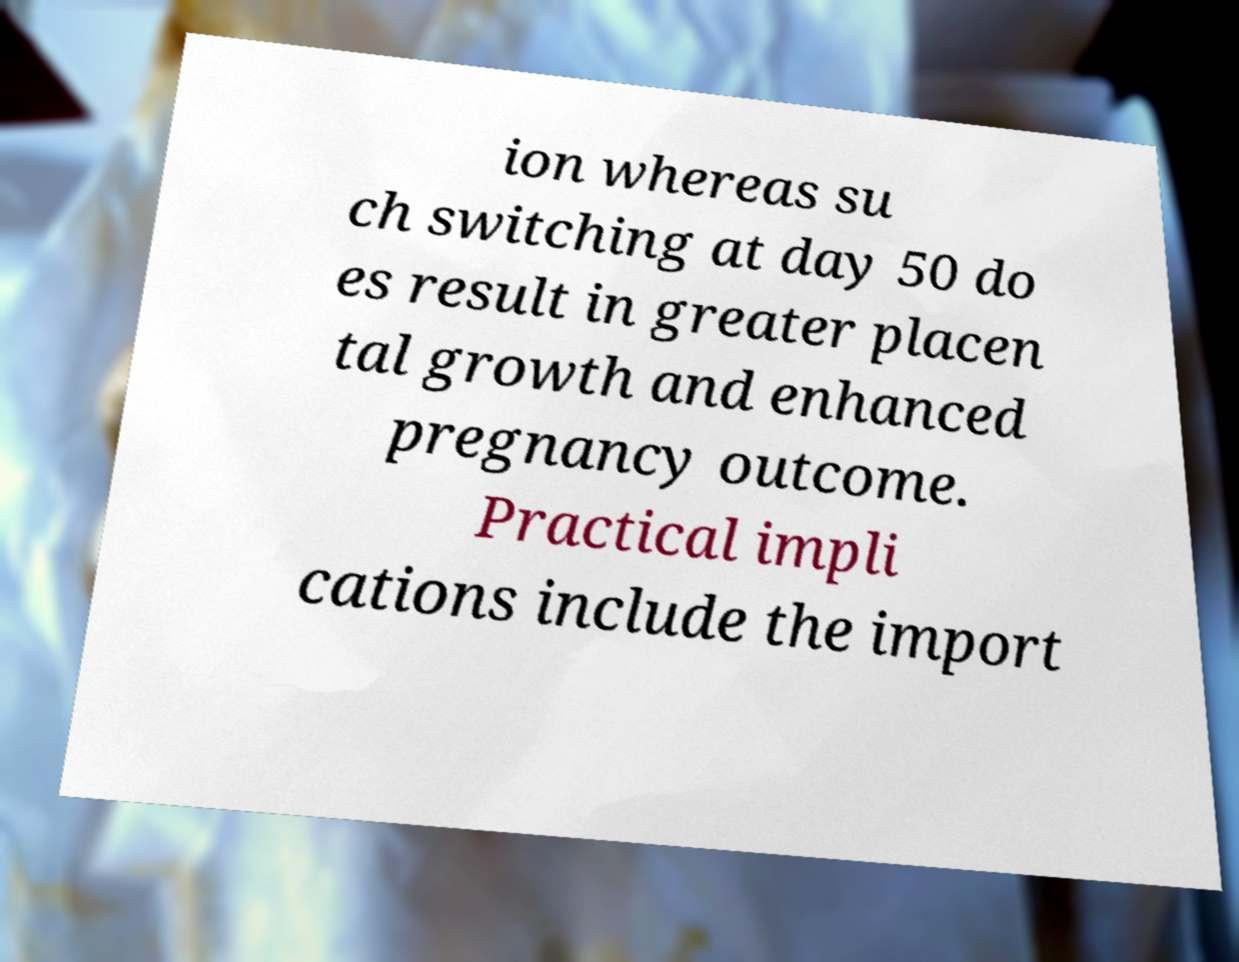What messages or text are displayed in this image? I need them in a readable, typed format. ion whereas su ch switching at day 50 do es result in greater placen tal growth and enhanced pregnancy outcome. Practical impli cations include the import 